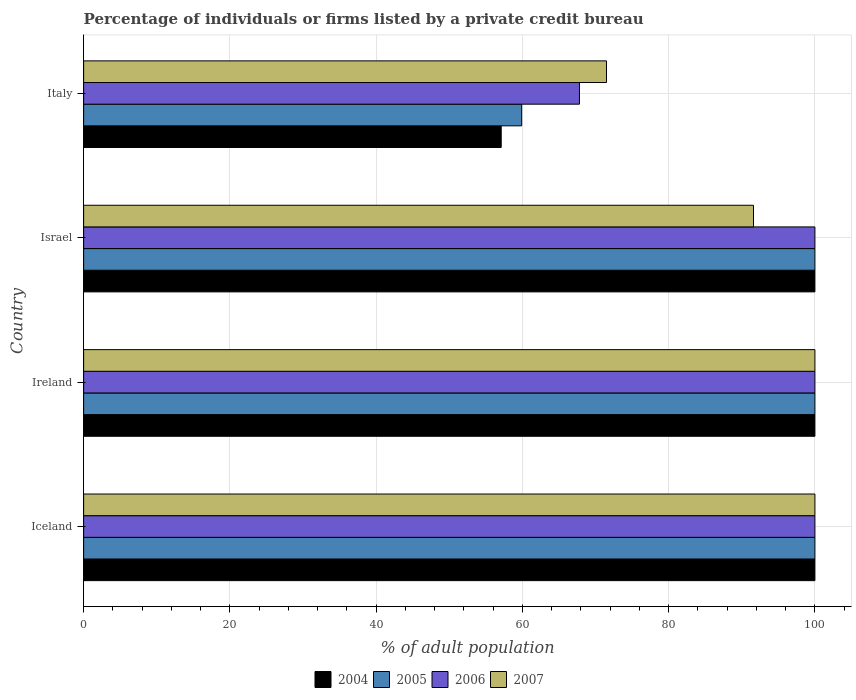How many different coloured bars are there?
Offer a terse response. 4. Are the number of bars on each tick of the Y-axis equal?
Ensure brevity in your answer.  Yes. What is the label of the 3rd group of bars from the top?
Your response must be concise. Ireland. In how many cases, is the number of bars for a given country not equal to the number of legend labels?
Provide a succinct answer. 0. Across all countries, what is the maximum percentage of population listed by a private credit bureau in 2004?
Provide a succinct answer. 100. Across all countries, what is the minimum percentage of population listed by a private credit bureau in 2004?
Ensure brevity in your answer.  57.1. In which country was the percentage of population listed by a private credit bureau in 2004 minimum?
Ensure brevity in your answer.  Italy. What is the total percentage of population listed by a private credit bureau in 2007 in the graph?
Keep it short and to the point. 363.1. What is the difference between the percentage of population listed by a private credit bureau in 2004 in Italy and the percentage of population listed by a private credit bureau in 2005 in Iceland?
Keep it short and to the point. -42.9. What is the average percentage of population listed by a private credit bureau in 2007 per country?
Your response must be concise. 90.78. What is the difference between the percentage of population listed by a private credit bureau in 2004 and percentage of population listed by a private credit bureau in 2005 in Israel?
Your answer should be compact. 0. Is the difference between the percentage of population listed by a private credit bureau in 2004 in Ireland and Italy greater than the difference between the percentage of population listed by a private credit bureau in 2005 in Ireland and Italy?
Your answer should be very brief. Yes. What is the difference between the highest and the lowest percentage of population listed by a private credit bureau in 2006?
Ensure brevity in your answer.  32.2. In how many countries, is the percentage of population listed by a private credit bureau in 2005 greater than the average percentage of population listed by a private credit bureau in 2005 taken over all countries?
Offer a very short reply. 3. Is the sum of the percentage of population listed by a private credit bureau in 2004 in Iceland and Israel greater than the maximum percentage of population listed by a private credit bureau in 2006 across all countries?
Offer a terse response. Yes. How many bars are there?
Keep it short and to the point. 16. Are the values on the major ticks of X-axis written in scientific E-notation?
Offer a very short reply. No. How many legend labels are there?
Offer a terse response. 4. What is the title of the graph?
Provide a succinct answer. Percentage of individuals or firms listed by a private credit bureau. What is the label or title of the X-axis?
Keep it short and to the point. % of adult population. What is the % of adult population of 2005 in Iceland?
Ensure brevity in your answer.  100. What is the % of adult population in 2005 in Ireland?
Keep it short and to the point. 100. What is the % of adult population of 2006 in Ireland?
Give a very brief answer. 100. What is the % of adult population in 2004 in Israel?
Your answer should be compact. 100. What is the % of adult population in 2006 in Israel?
Your response must be concise. 100. What is the % of adult population of 2007 in Israel?
Your answer should be very brief. 91.6. What is the % of adult population of 2004 in Italy?
Keep it short and to the point. 57.1. What is the % of adult population in 2005 in Italy?
Provide a succinct answer. 59.9. What is the % of adult population of 2006 in Italy?
Make the answer very short. 67.8. What is the % of adult population of 2007 in Italy?
Provide a succinct answer. 71.5. Across all countries, what is the maximum % of adult population of 2005?
Your answer should be compact. 100. Across all countries, what is the maximum % of adult population of 2006?
Your answer should be very brief. 100. Across all countries, what is the maximum % of adult population in 2007?
Your response must be concise. 100. Across all countries, what is the minimum % of adult population of 2004?
Provide a succinct answer. 57.1. Across all countries, what is the minimum % of adult population of 2005?
Ensure brevity in your answer.  59.9. Across all countries, what is the minimum % of adult population in 2006?
Offer a very short reply. 67.8. Across all countries, what is the minimum % of adult population in 2007?
Give a very brief answer. 71.5. What is the total % of adult population in 2004 in the graph?
Offer a terse response. 357.1. What is the total % of adult population in 2005 in the graph?
Ensure brevity in your answer.  359.9. What is the total % of adult population in 2006 in the graph?
Make the answer very short. 367.8. What is the total % of adult population in 2007 in the graph?
Offer a very short reply. 363.1. What is the difference between the % of adult population in 2004 in Iceland and that in Ireland?
Make the answer very short. 0. What is the difference between the % of adult population of 2007 in Iceland and that in Ireland?
Your answer should be very brief. 0. What is the difference between the % of adult population in 2004 in Iceland and that in Israel?
Give a very brief answer. 0. What is the difference between the % of adult population in 2004 in Iceland and that in Italy?
Ensure brevity in your answer.  42.9. What is the difference between the % of adult population of 2005 in Iceland and that in Italy?
Offer a terse response. 40.1. What is the difference between the % of adult population of 2006 in Iceland and that in Italy?
Offer a very short reply. 32.2. What is the difference between the % of adult population in 2005 in Ireland and that in Israel?
Make the answer very short. 0. What is the difference between the % of adult population of 2004 in Ireland and that in Italy?
Provide a short and direct response. 42.9. What is the difference between the % of adult population in 2005 in Ireland and that in Italy?
Keep it short and to the point. 40.1. What is the difference between the % of adult population in 2006 in Ireland and that in Italy?
Make the answer very short. 32.2. What is the difference between the % of adult population of 2004 in Israel and that in Italy?
Give a very brief answer. 42.9. What is the difference between the % of adult population in 2005 in Israel and that in Italy?
Your answer should be very brief. 40.1. What is the difference between the % of adult population in 2006 in Israel and that in Italy?
Ensure brevity in your answer.  32.2. What is the difference between the % of adult population of 2007 in Israel and that in Italy?
Offer a terse response. 20.1. What is the difference between the % of adult population of 2004 in Iceland and the % of adult population of 2005 in Ireland?
Provide a succinct answer. 0. What is the difference between the % of adult population in 2005 in Iceland and the % of adult population in 2006 in Ireland?
Offer a terse response. 0. What is the difference between the % of adult population of 2005 in Iceland and the % of adult population of 2007 in Ireland?
Keep it short and to the point. 0. What is the difference between the % of adult population of 2004 in Iceland and the % of adult population of 2005 in Israel?
Your answer should be compact. 0. What is the difference between the % of adult population of 2004 in Iceland and the % of adult population of 2007 in Israel?
Your answer should be compact. 8.4. What is the difference between the % of adult population in 2005 in Iceland and the % of adult population in 2006 in Israel?
Your answer should be very brief. 0. What is the difference between the % of adult population in 2004 in Iceland and the % of adult population in 2005 in Italy?
Ensure brevity in your answer.  40.1. What is the difference between the % of adult population in 2004 in Iceland and the % of adult population in 2006 in Italy?
Offer a terse response. 32.2. What is the difference between the % of adult population of 2005 in Iceland and the % of adult population of 2006 in Italy?
Keep it short and to the point. 32.2. What is the difference between the % of adult population of 2004 in Ireland and the % of adult population of 2005 in Israel?
Provide a short and direct response. 0. What is the difference between the % of adult population in 2004 in Ireland and the % of adult population in 2006 in Israel?
Keep it short and to the point. 0. What is the difference between the % of adult population in 2004 in Ireland and the % of adult population in 2007 in Israel?
Your response must be concise. 8.4. What is the difference between the % of adult population of 2005 in Ireland and the % of adult population of 2007 in Israel?
Provide a succinct answer. 8.4. What is the difference between the % of adult population of 2004 in Ireland and the % of adult population of 2005 in Italy?
Your answer should be very brief. 40.1. What is the difference between the % of adult population in 2004 in Ireland and the % of adult population in 2006 in Italy?
Your answer should be compact. 32.2. What is the difference between the % of adult population in 2004 in Ireland and the % of adult population in 2007 in Italy?
Your answer should be compact. 28.5. What is the difference between the % of adult population of 2005 in Ireland and the % of adult population of 2006 in Italy?
Keep it short and to the point. 32.2. What is the difference between the % of adult population of 2005 in Ireland and the % of adult population of 2007 in Italy?
Offer a very short reply. 28.5. What is the difference between the % of adult population in 2006 in Ireland and the % of adult population in 2007 in Italy?
Give a very brief answer. 28.5. What is the difference between the % of adult population of 2004 in Israel and the % of adult population of 2005 in Italy?
Ensure brevity in your answer.  40.1. What is the difference between the % of adult population of 2004 in Israel and the % of adult population of 2006 in Italy?
Ensure brevity in your answer.  32.2. What is the difference between the % of adult population in 2005 in Israel and the % of adult population in 2006 in Italy?
Ensure brevity in your answer.  32.2. What is the difference between the % of adult population in 2006 in Israel and the % of adult population in 2007 in Italy?
Keep it short and to the point. 28.5. What is the average % of adult population in 2004 per country?
Provide a short and direct response. 89.28. What is the average % of adult population of 2005 per country?
Give a very brief answer. 89.97. What is the average % of adult population in 2006 per country?
Your answer should be very brief. 91.95. What is the average % of adult population in 2007 per country?
Ensure brevity in your answer.  90.78. What is the difference between the % of adult population in 2004 and % of adult population in 2006 in Iceland?
Give a very brief answer. 0. What is the difference between the % of adult population of 2005 and % of adult population of 2006 in Iceland?
Offer a very short reply. 0. What is the difference between the % of adult population of 2005 and % of adult population of 2007 in Iceland?
Give a very brief answer. 0. What is the difference between the % of adult population of 2006 and % of adult population of 2007 in Iceland?
Give a very brief answer. 0. What is the difference between the % of adult population of 2004 and % of adult population of 2005 in Ireland?
Offer a very short reply. 0. What is the difference between the % of adult population of 2004 and % of adult population of 2006 in Ireland?
Ensure brevity in your answer.  0. What is the difference between the % of adult population of 2004 and % of adult population of 2006 in Israel?
Provide a succinct answer. 0. What is the difference between the % of adult population of 2004 and % of adult population of 2007 in Israel?
Ensure brevity in your answer.  8.4. What is the difference between the % of adult population of 2005 and % of adult population of 2006 in Israel?
Provide a succinct answer. 0. What is the difference between the % of adult population of 2005 and % of adult population of 2007 in Israel?
Your answer should be compact. 8.4. What is the difference between the % of adult population in 2006 and % of adult population in 2007 in Israel?
Keep it short and to the point. 8.4. What is the difference between the % of adult population in 2004 and % of adult population in 2005 in Italy?
Make the answer very short. -2.8. What is the difference between the % of adult population in 2004 and % of adult population in 2007 in Italy?
Provide a short and direct response. -14.4. What is the difference between the % of adult population of 2006 and % of adult population of 2007 in Italy?
Your answer should be compact. -3.7. What is the ratio of the % of adult population of 2004 in Iceland to that in Israel?
Offer a very short reply. 1. What is the ratio of the % of adult population in 2006 in Iceland to that in Israel?
Your answer should be compact. 1. What is the ratio of the % of adult population in 2007 in Iceland to that in Israel?
Make the answer very short. 1.09. What is the ratio of the % of adult population of 2004 in Iceland to that in Italy?
Make the answer very short. 1.75. What is the ratio of the % of adult population of 2005 in Iceland to that in Italy?
Provide a succinct answer. 1.67. What is the ratio of the % of adult population in 2006 in Iceland to that in Italy?
Your response must be concise. 1.47. What is the ratio of the % of adult population of 2007 in Iceland to that in Italy?
Your answer should be very brief. 1.4. What is the ratio of the % of adult population of 2006 in Ireland to that in Israel?
Give a very brief answer. 1. What is the ratio of the % of adult population of 2007 in Ireland to that in Israel?
Offer a very short reply. 1.09. What is the ratio of the % of adult population in 2004 in Ireland to that in Italy?
Offer a very short reply. 1.75. What is the ratio of the % of adult population of 2005 in Ireland to that in Italy?
Offer a terse response. 1.67. What is the ratio of the % of adult population in 2006 in Ireland to that in Italy?
Provide a short and direct response. 1.47. What is the ratio of the % of adult population of 2007 in Ireland to that in Italy?
Provide a succinct answer. 1.4. What is the ratio of the % of adult population in 2004 in Israel to that in Italy?
Make the answer very short. 1.75. What is the ratio of the % of adult population of 2005 in Israel to that in Italy?
Provide a succinct answer. 1.67. What is the ratio of the % of adult population of 2006 in Israel to that in Italy?
Your response must be concise. 1.47. What is the ratio of the % of adult population in 2007 in Israel to that in Italy?
Give a very brief answer. 1.28. What is the difference between the highest and the second highest % of adult population in 2005?
Provide a succinct answer. 0. What is the difference between the highest and the second highest % of adult population in 2006?
Ensure brevity in your answer.  0. What is the difference between the highest and the second highest % of adult population of 2007?
Give a very brief answer. 0. What is the difference between the highest and the lowest % of adult population in 2004?
Your response must be concise. 42.9. What is the difference between the highest and the lowest % of adult population in 2005?
Give a very brief answer. 40.1. What is the difference between the highest and the lowest % of adult population in 2006?
Your answer should be very brief. 32.2. 